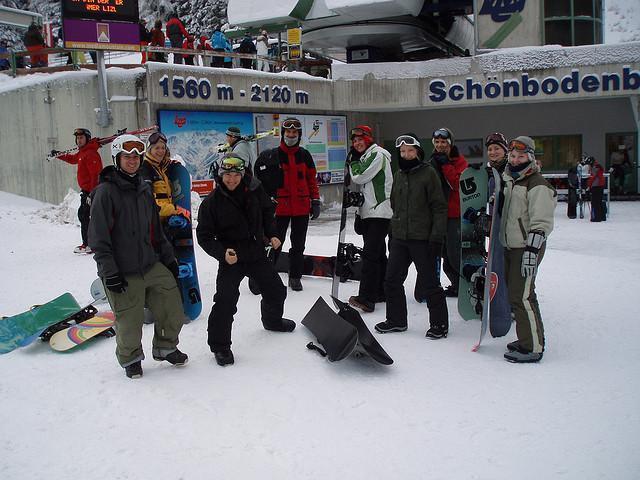This photo was taken in front of what kind of attraction?
Choose the correct response and explain in the format: 'Answer: answer
Rationale: rationale.'
Options: View point, restaurant, ski lodge, museum. Answer: ski lodge.
Rationale: There is a lot of snow and ski equipment with them 